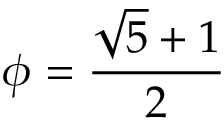<formula> <loc_0><loc_0><loc_500><loc_500>\phi = { \frac { { \sqrt { 5 } } + 1 } { 2 } }</formula> 